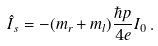Convert formula to latex. <formula><loc_0><loc_0><loc_500><loc_500>\hat { I } _ { s } = - ( { m } _ { r } + { m } _ { l } ) \frac { \hbar { p } } { 4 e } I _ { 0 } \, .</formula> 